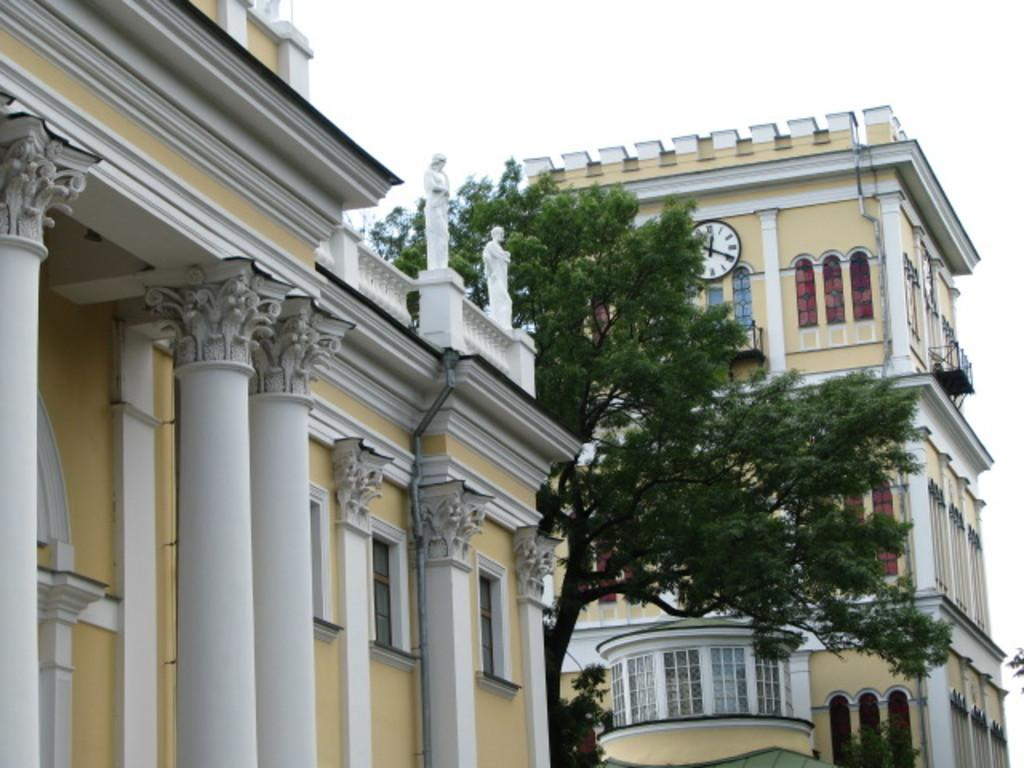What type of structures can be seen in the image? There are buildings in the image. What natural element is present in the image? There is a tree in the image. What time-telling device is visible in the image? There is a clock in the image. What type of artwork can be seen in the image? There are sculptures in the image. What is visible in the background of the image? The sky is visible in the image. What type of jam is being used to create the sculptures in the image? There is no jam present in the image; the sculptures are made of a different material. What scientific experiment is being conducted in the image? There is no scientific experiment visible in the image; it features buildings, a tree, a clock, sculptures, and the sky. 